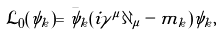Convert formula to latex. <formula><loc_0><loc_0><loc_500><loc_500>\mathcal { L } _ { 0 } ( \psi _ { k } ) = \bar { \psi } _ { k } ( i \gamma ^ { \mu } \partial _ { \mu } - m _ { k } ) \psi _ { k } ,</formula> 